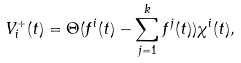Convert formula to latex. <formula><loc_0><loc_0><loc_500><loc_500>V _ { i } ^ { + } ( t ) = \Theta ( f ^ { i } ( t ) - \sum _ { j = 1 } ^ { k } f ^ { j } ( t ) ) \chi ^ { i } ( t ) ,</formula> 